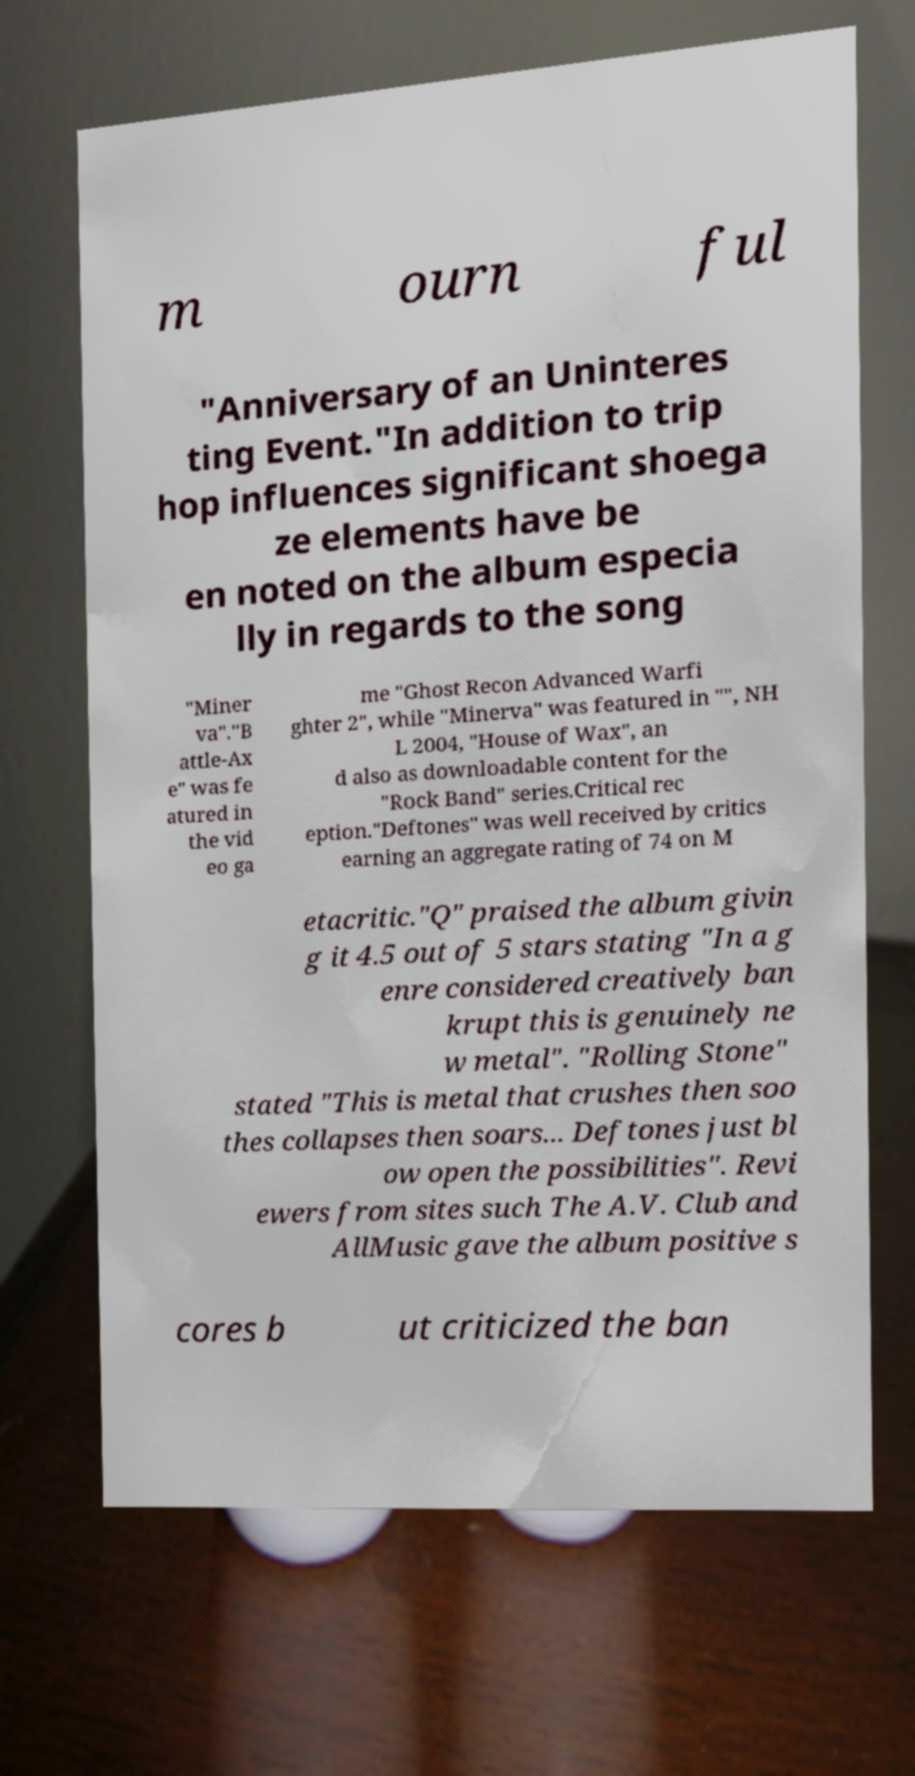Could you assist in decoding the text presented in this image and type it out clearly? m ourn ful "Anniversary of an Uninteres ting Event."In addition to trip hop influences significant shoega ze elements have be en noted on the album especia lly in regards to the song "Miner va"."B attle-Ax e" was fe atured in the vid eo ga me "Ghost Recon Advanced Warfi ghter 2", while "Minerva" was featured in "", NH L 2004, "House of Wax", an d also as downloadable content for the "Rock Band" series.Critical rec eption."Deftones" was well received by critics earning an aggregate rating of 74 on M etacritic."Q" praised the album givin g it 4.5 out of 5 stars stating "In a g enre considered creatively ban krupt this is genuinely ne w metal". "Rolling Stone" stated "This is metal that crushes then soo thes collapses then soars... Deftones just bl ow open the possibilities". Revi ewers from sites such The A.V. Club and AllMusic gave the album positive s cores b ut criticized the ban 